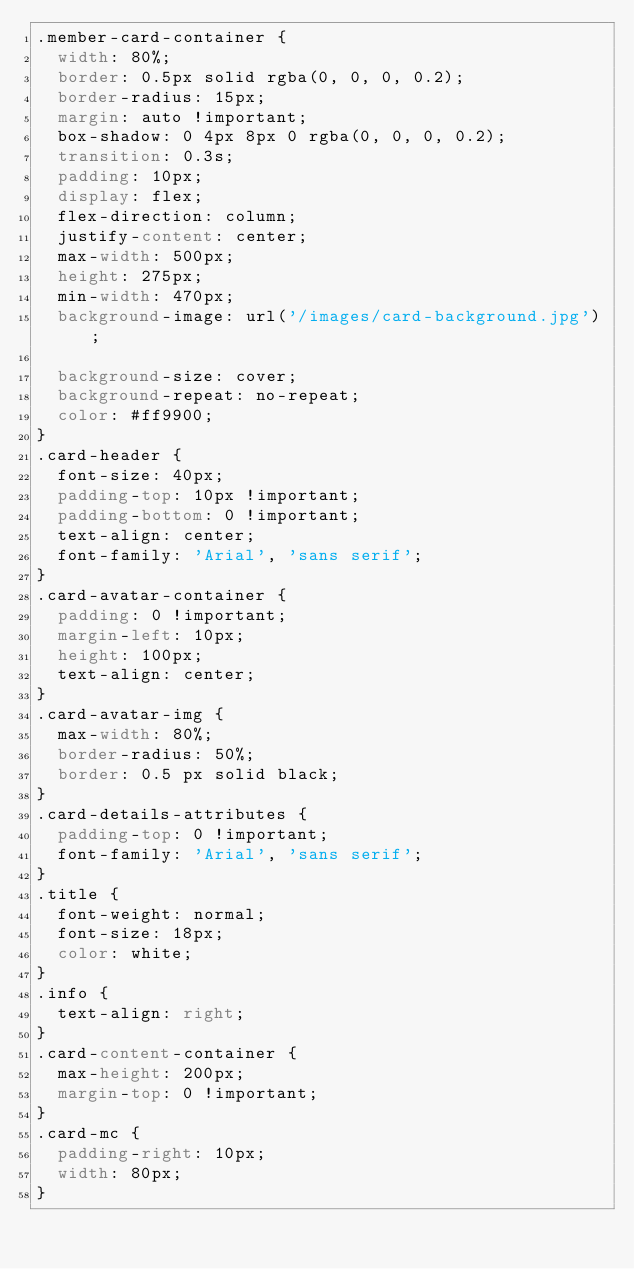<code> <loc_0><loc_0><loc_500><loc_500><_CSS_>.member-card-container {
  width: 80%;
  border: 0.5px solid rgba(0, 0, 0, 0.2);
  border-radius: 15px;
  margin: auto !important;
  box-shadow: 0 4px 8px 0 rgba(0, 0, 0, 0.2);
  transition: 0.3s;
  padding: 10px;
  display: flex;
  flex-direction: column;
  justify-content: center;
  max-width: 500px;
  height: 275px;
  min-width: 470px;
  background-image: url('/images/card-background.jpg');

  background-size: cover;
  background-repeat: no-repeat;
  color: #ff9900;
}
.card-header {
  font-size: 40px;
  padding-top: 10px !important;
  padding-bottom: 0 !important;
  text-align: center;
  font-family: 'Arial', 'sans serif';
}
.card-avatar-container {
  padding: 0 !important;
  margin-left: 10px;
  height: 100px;
  text-align: center;
}
.card-avatar-img {
  max-width: 80%;
  border-radius: 50%;
  border: 0.5 px solid black;
}
.card-details-attributes {
  padding-top: 0 !important;
  font-family: 'Arial', 'sans serif';
}
.title {
  font-weight: normal;
  font-size: 18px;
  color: white;
}
.info {
  text-align: right;
}
.card-content-container {
  max-height: 200px;
  margin-top: 0 !important;
}
.card-mc {
  padding-right: 10px;
  width: 80px;
}
</code> 